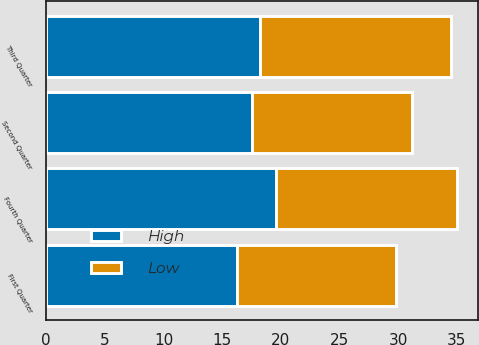Convert chart. <chart><loc_0><loc_0><loc_500><loc_500><stacked_bar_chart><ecel><fcel>Fourth Quarter<fcel>Third Quarter<fcel>Second Quarter<fcel>First Quarter<nl><fcel>High<fcel>19.54<fcel>18.25<fcel>17.55<fcel>16.25<nl><fcel>Low<fcel>15.5<fcel>16.25<fcel>13.63<fcel>13.59<nl></chart> 